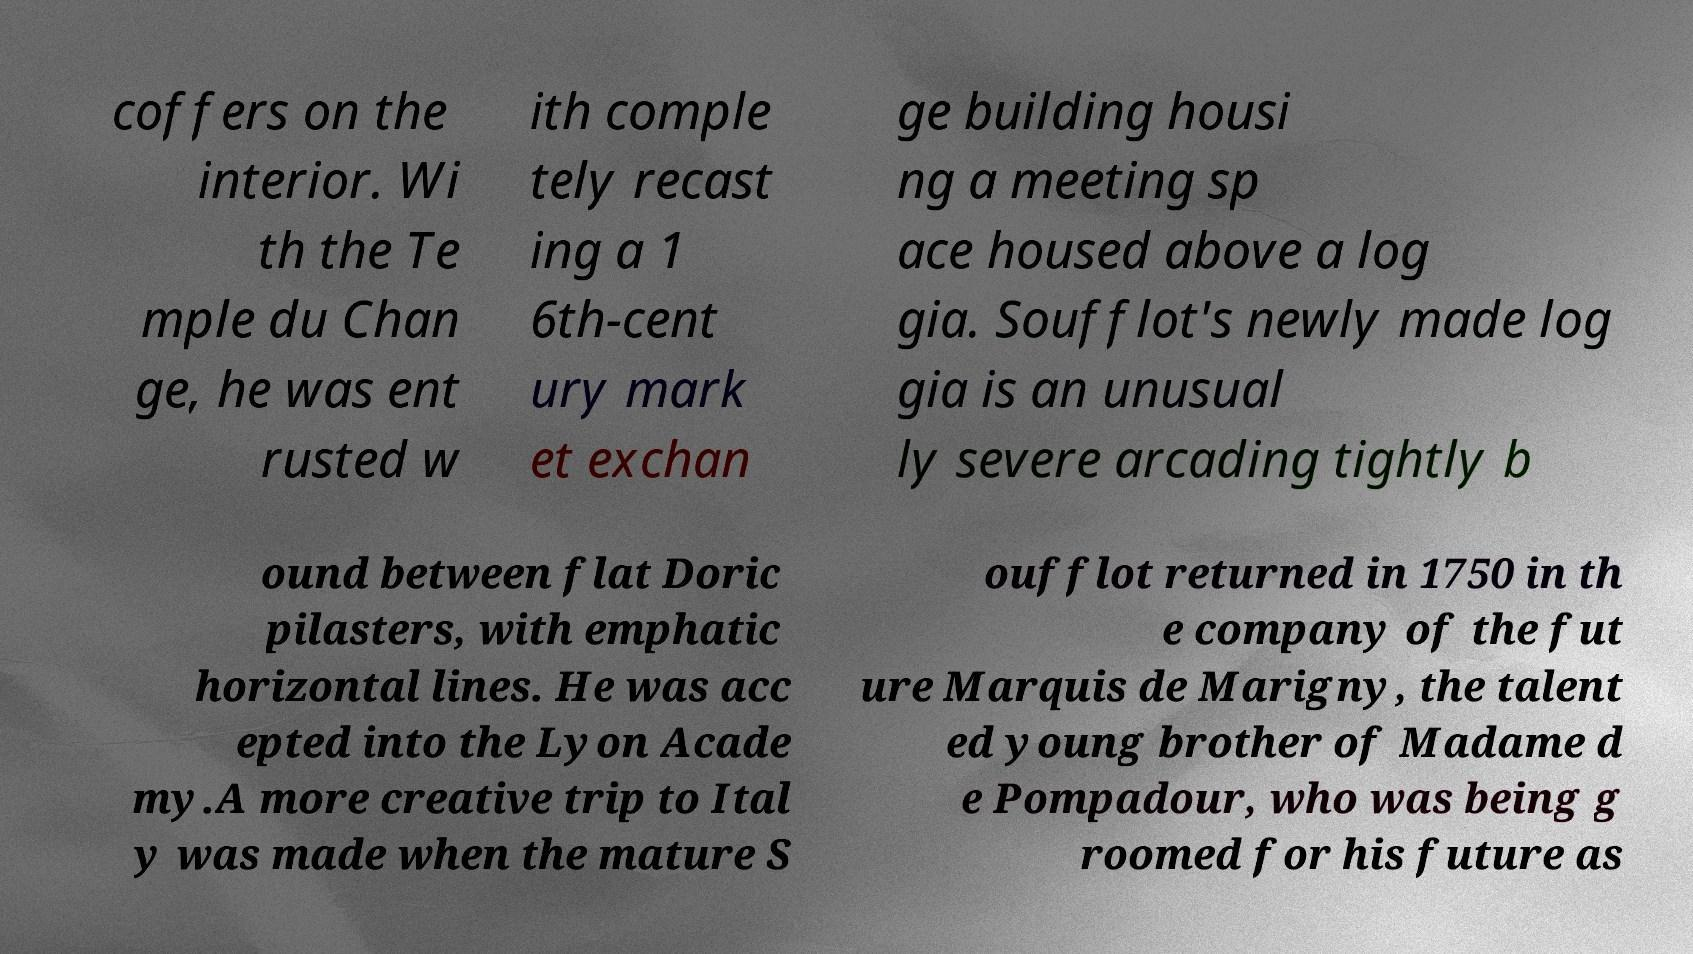Can you accurately transcribe the text from the provided image for me? coffers on the interior. Wi th the Te mple du Chan ge, he was ent rusted w ith comple tely recast ing a 1 6th-cent ury mark et exchan ge building housi ng a meeting sp ace housed above a log gia. Soufflot's newly made log gia is an unusual ly severe arcading tightly b ound between flat Doric pilasters, with emphatic horizontal lines. He was acc epted into the Lyon Acade my.A more creative trip to Ital y was made when the mature S oufflot returned in 1750 in th e company of the fut ure Marquis de Marigny, the talent ed young brother of Madame d e Pompadour, who was being g roomed for his future as 